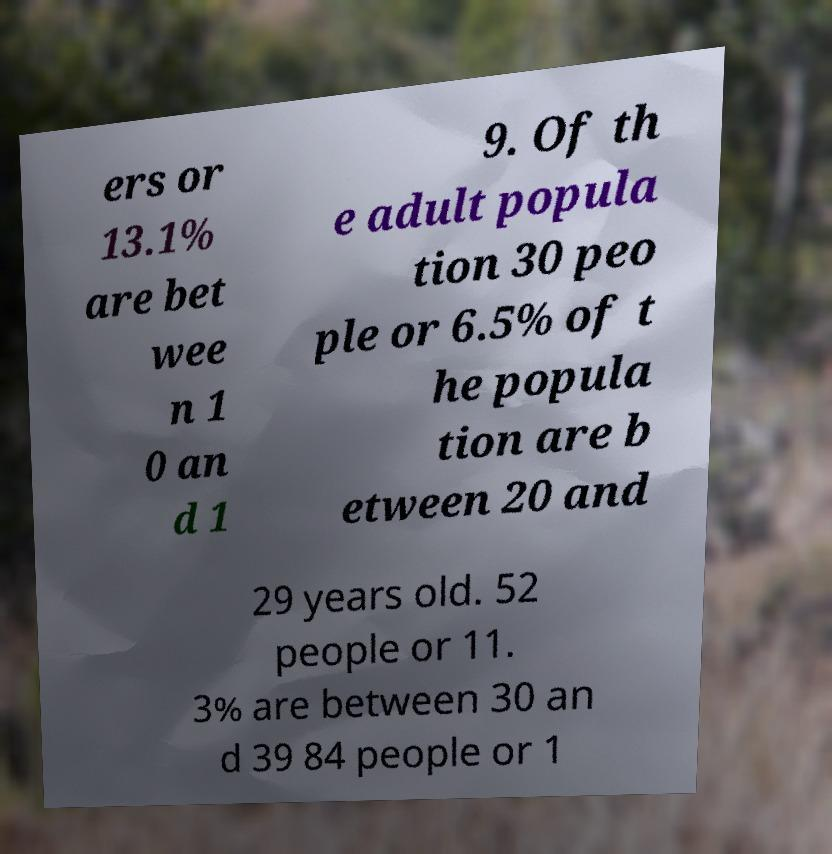What messages or text are displayed in this image? I need them in a readable, typed format. ers or 13.1% are bet wee n 1 0 an d 1 9. Of th e adult popula tion 30 peo ple or 6.5% of t he popula tion are b etween 20 and 29 years old. 52 people or 11. 3% are between 30 an d 39 84 people or 1 